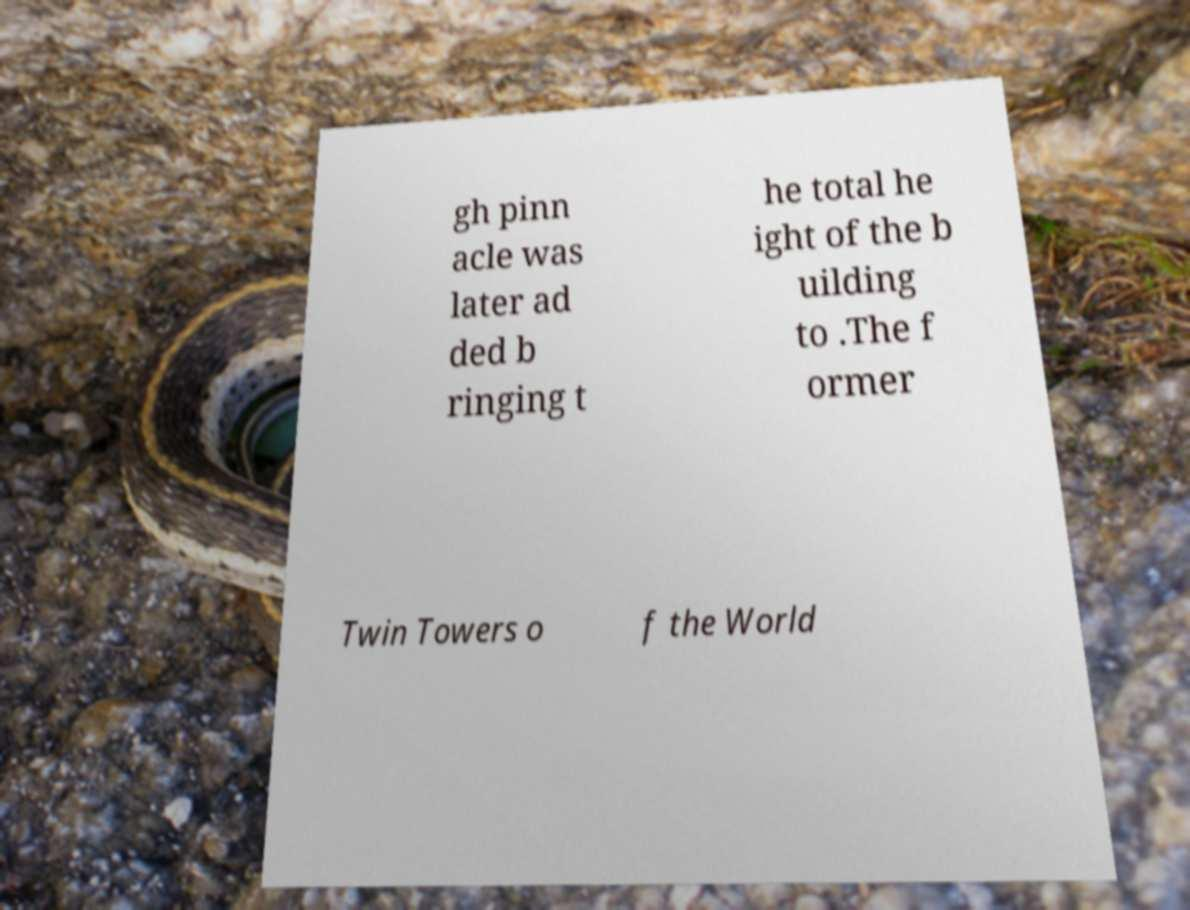Can you read and provide the text displayed in the image?This photo seems to have some interesting text. Can you extract and type it out for me? gh pinn acle was later ad ded b ringing t he total he ight of the b uilding to .The f ormer Twin Towers o f the World 